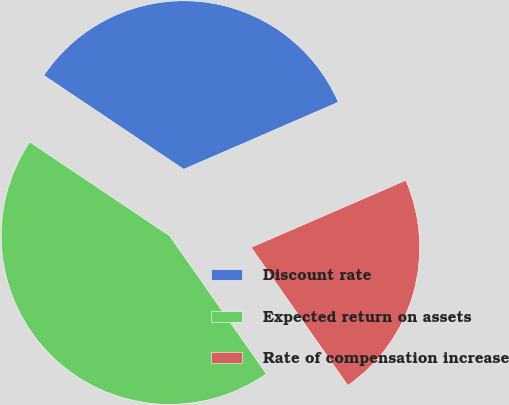Convert chart to OTSL. <chart><loc_0><loc_0><loc_500><loc_500><pie_chart><fcel>Discount rate<fcel>Expected return on assets<fcel>Rate of compensation increase<nl><fcel>34.08%<fcel>44.13%<fcel>21.79%<nl></chart> 